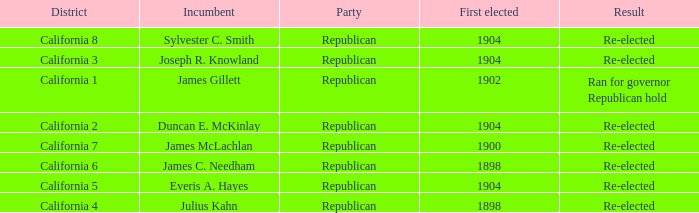Which District has a Result of Re-elected and a First Elected of 1898? California 4, California 6. I'm looking to parse the entire table for insights. Could you assist me with that? {'header': ['District', 'Incumbent', 'Party', 'First elected', 'Result'], 'rows': [['California 8', 'Sylvester C. Smith', 'Republican', '1904', 'Re-elected'], ['California 3', 'Joseph R. Knowland', 'Republican', '1904', 'Re-elected'], ['California 1', 'James Gillett', 'Republican', '1902', 'Ran for governor Republican hold'], ['California 2', 'Duncan E. McKinlay', 'Republican', '1904', 'Re-elected'], ['California 7', 'James McLachlan', 'Republican', '1900', 'Re-elected'], ['California 6', 'James C. Needham', 'Republican', '1898', 'Re-elected'], ['California 5', 'Everis A. Hayes', 'Republican', '1904', 'Re-elected'], ['California 4', 'Julius Kahn', 'Republican', '1898', 'Re-elected']]} 